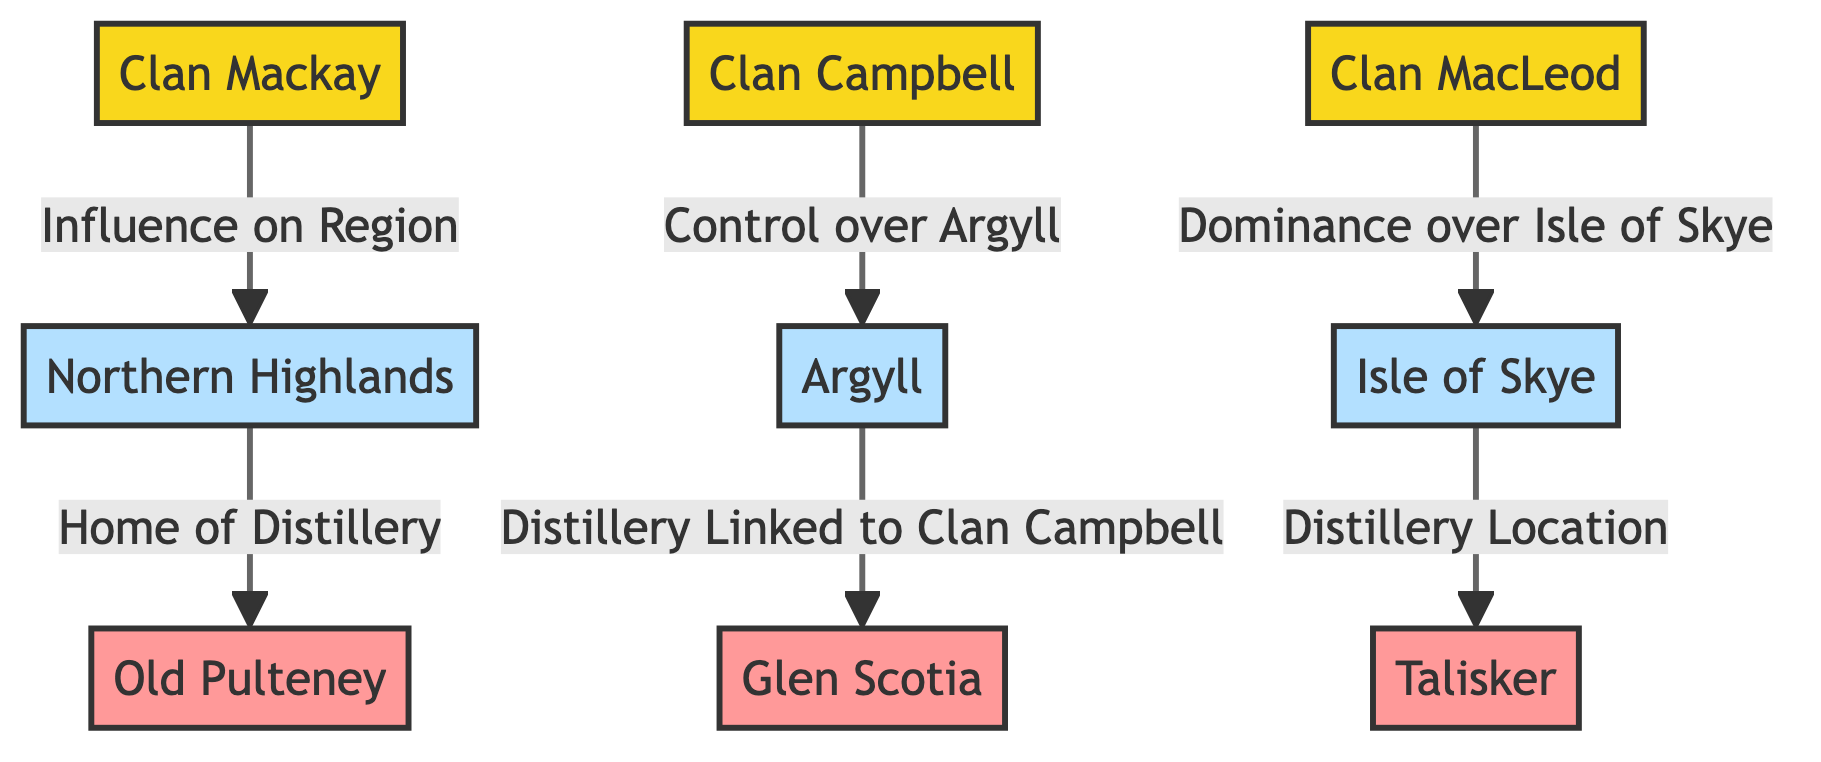How many clans are represented in the diagram? The diagram contains three clans: Clan Mackay, Clan Campbell, and Clan MacLeod. Each clan is represented as a distinct node without any duplicates, so the total count is simply the number of clan nodes shown.
Answer: 3 Which clan has influence over the Northern Highlands? The diagram indicates that Clan Mackay has a direct influence on the Northern Highlands, as shown by the arrow pointing from Clan Mackay to the Northern Highlands node.
Answer: Clan Mackay What distillery is linked to Clan Campbell? According to the diagram, Glen Scotia is linked to Clan Campbell, which is indicated by the arrow from the Argyll region (controlled by Clan Campbell) to the Glen Scotia distillery.
Answer: Glen Scotia How many distilleries are represented in the diagram? There are three distilleries represented in the diagram: Old Pulteney, Talisker, and Glen Scotia. Each distillery is connected to a region, indicating their locations, and the count results from tallying the distillery nodes shown.
Answer: 3 Which region is associated with Old Pulteney? The diagram shows that Old Pulteney is associated with the Northern Highlands region, as indicated by the arrow pointing from the Northern Highlands node to the Old Pulteney distillery node.
Answer: Northern Highlands What is the relationship between Clan MacLeod and the Isle of Skye? Clan MacLeod has dominance over the Isle of Skye, which is explicitly stated in the diagram with the arrow labeled 'Dominance over Isle of Skye' connecting Clan MacLeod to the Isle of Skye node.
Answer: Dominance Which region does Talisker belong to? The diagram shows that Talisker is located in the Isle of Skye region, marked by the direct connection from the Isle of Skye node to the Talisker distillery node.
Answer: Isle of Skye What is the significance of Clan Campbell in relation to Argyll? Clan Campbell has control over Argyll, represented by the labeling of the arrow between Clan Campbell and the Argyll region in the diagram. This illustrates the influence of Clan Campbell on the region's whisky production.
Answer: Control How does Clan Mackay influence whisky production? Clan Mackay influences whisky production through its connection to the Northern Highlands, which is the home of the Old Pulteney distillery, demonstrating the clan's impact on production in this region.
Answer: Through Northern Highlands 